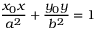Convert formula to latex. <formula><loc_0><loc_0><loc_500><loc_500>{ \frac { x _ { 0 } x } { a ^ { 2 } } } + { \frac { y _ { 0 } y } { b ^ { 2 } } } = 1</formula> 